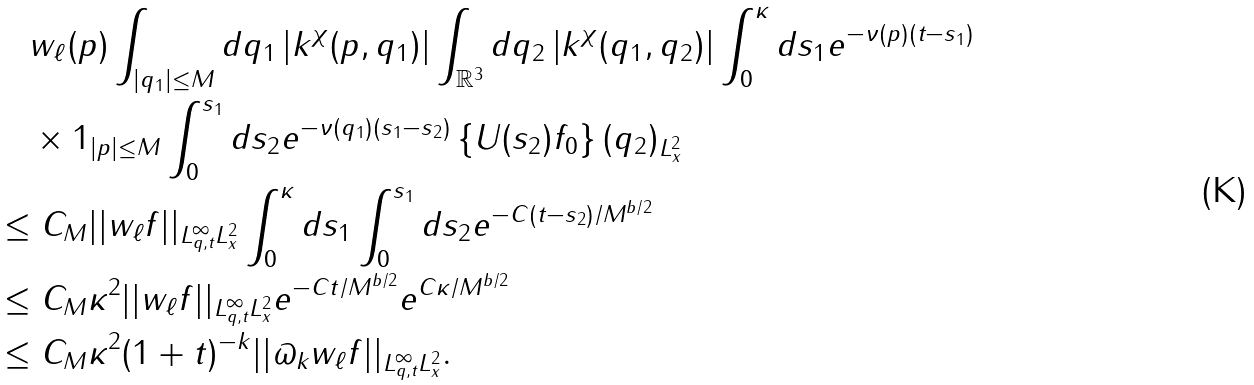<formula> <loc_0><loc_0><loc_500><loc_500>& \quad w _ { \ell } ( p ) \int _ { | q _ { 1 } | \leq M } d q _ { 1 } \left | k ^ { \chi } ( p , q _ { 1 } ) \right | \int _ { \mathbb { R } ^ { 3 } } d q _ { 2 } \left | k ^ { \chi } ( q _ { 1 } , q _ { 2 } ) \right | \int _ { 0 } ^ { \kappa } d s _ { 1 } e ^ { - \nu ( p ) ( t - s _ { 1 } ) } \\ & \quad \times { 1 } _ { | p | \leq M } \int _ { 0 } ^ { s _ { 1 } } d s _ { 2 } e ^ { - \nu ( q _ { 1 } ) ( s _ { 1 } - s _ { 2 } ) } \| \left \{ U ( s _ { 2 } ) f _ { 0 } \right \} ( q _ { 2 } ) \| _ { L ^ { 2 } _ { x } } \\ & \leq C _ { M } | | w _ { \ell } f | | _ { L ^ { \infty } _ { q , t } L ^ { 2 } _ { x } } \int _ { 0 } ^ { \kappa } d s _ { 1 } \int _ { 0 } ^ { s _ { 1 } } d s _ { 2 } e ^ { - C ( t - s _ { 2 } ) / M ^ { b / 2 } } \\ & \leq C _ { M } \kappa ^ { 2 } | | w _ { \ell } f | | _ { L ^ { \infty } _ { q , t } L ^ { 2 } _ { x } } e ^ { - C t / M ^ { b / 2 } } e ^ { C \kappa / M ^ { b / 2 } } \\ & \leq C _ { M } \kappa ^ { 2 } ( 1 + t ) ^ { - k } | | \varpi _ { k } w _ { \ell } f | | _ { L ^ { \infty } _ { q , t } L ^ { 2 } _ { x } } .</formula> 